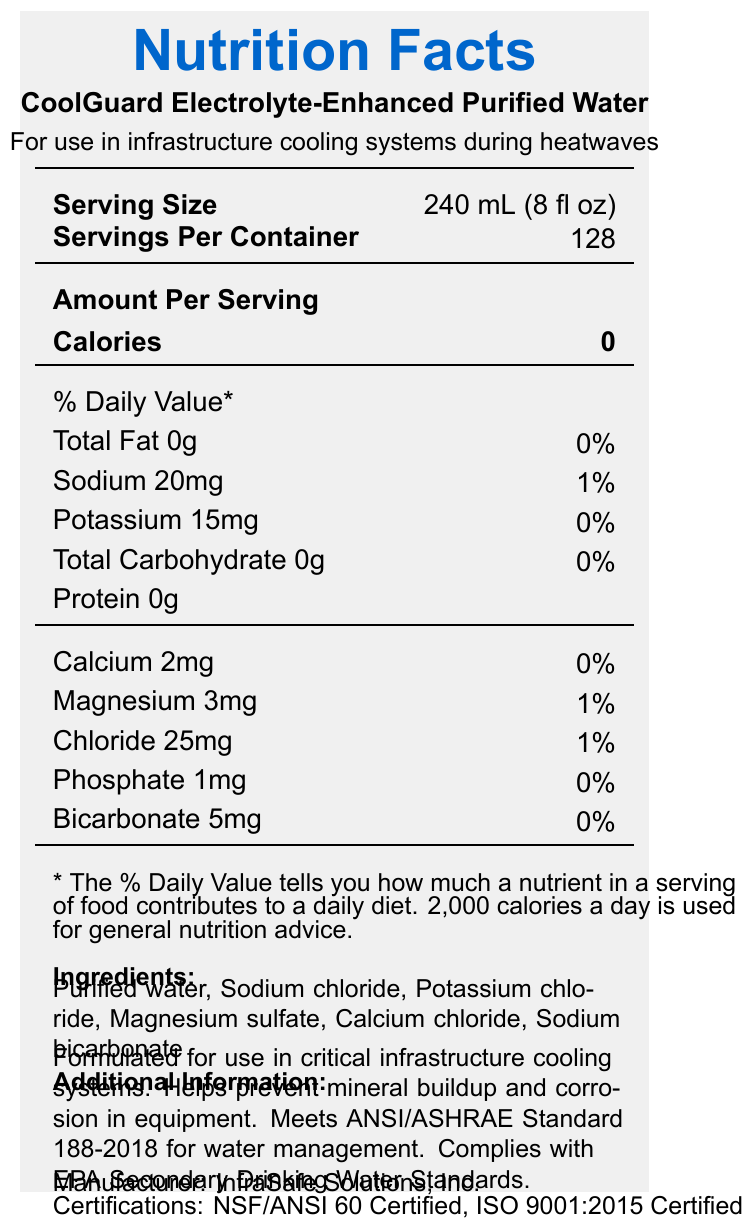what is the serving size? The serving size is explicitly stated in the document as 240 mL (8 fl oz).
Answer: 240 mL (8 fl oz) how much sodium is in one serving? The document specifies that each serving contains 20 mg of sodium.
Answer: 20 mg who is the manufacturer of CoolGuard Electrolyte-Enhanced Purified Water? The manufacturer is listed in the document as InfraSafe Solutions, Inc.
Answer: InfraSafe Solutions, Inc. how much potassium is in one serving? The document states that each serving contains 15 mg of potassium.
Answer: 15 mg what should you do to store this product properly? The document provides storage instructions which specify keeping the product in a cool, dry place away from direct sunlight.
Answer: Store in a cool, dry place away from direct sunlight how many servings are there per container? According to the document, there are 128 servings per container.
Answer: 128 what is the expiration date of the product? The expiration date is stated to be 24 months from the date of manufacture in the document.
Answer: 24 months from date of manufacture what is the daily value percentage of calcium in one serving? The document lists the daily value percentage for calcium as 0% per serving.
Answer: 0% how many mg of bicarbonate are in one serving? The document specifies that there are 5 mg of bicarbonate in one serving.
Answer: 5 mg is this product suitable for human consumption in emergencies? The document states that it is suitable for human consumption in emergencies.
Answer: Yes which organization provides the certification NSF/ANSI 60? A. EPA B. InfraSafe Solutions, Inc. C. ANSI NSF/ANSI 60 Certified is a certification that involves ANSI (American National Standards Institute).
Answer: C how long should the product be used after opening? A. 7 days B. 14 days C. 30 days D. 60 days The document indicates that the product should be used within 30 days of opening.
Answer: C which of the following electrolytes is NOT listed as an ingredient in the product? A. Sodium chloride B. Potassium chloride C. Magnesium sulfate D. Sodium phosphate The ingredients list includes sodium chloride, potassium chloride, and magnesium sulfate but not sodium phosphate.
Answer: D does the product comply with the EPA Secondary Drinking Water Standards? The document states that the product complies with the EPA Secondary Drinking Water Standards.
Answer: Yes summarize the main attributes of CoolGuard Electrolyte-Enhanced Purified Water. This answer succinctly summarizes the key features and benefits of the product as stated in the document.
Answer: CoolGuard Electrolyte-Enhanced Purified Water is specifically formulated for use in critical infrastructure cooling systems during heatwaves. It contains added electrolytes such as sodium, potassium, calcium, and magnesium to prevent mineral buildup and corrosion in equipment. The product meets ANSI/ASHRAE Standard 188-2018 for water management and complies with EPA Secondary Drinking Water Standards. It is NSF/ANSI 60 and ISO 9001:2015 Certified. The manufacturer is InfraSafe Solutions, Inc., and it can also be used for human consumption in emergencies. Storage instructions recommend keeping it in a cool, dry place away from direct sunlight and using it within 30 days of opening. how many calories does each serving of CoolGuard Electrolyte-Enhanced Purified Water contain? The document clearly states that each serving contains 0 calories.
Answer: 0 what is the primary function of CoolGuard Electrolyte-Enhanced Purified Water according to the additional information? The additional information in the document specifies that the product helps prevent mineral buildup and corrosion in equipment.
Answer: Helps prevent mineral buildup and corrosion in equipment what is the weight of potassium per serving? The document lists the amount of potassium in milligrams but does not provide the weight in a different measure such as grams.
Answer: Not enough information what is the batch number of the product? The document provides the batch number as CG2023-0742.
Answer: CG2023-0742 